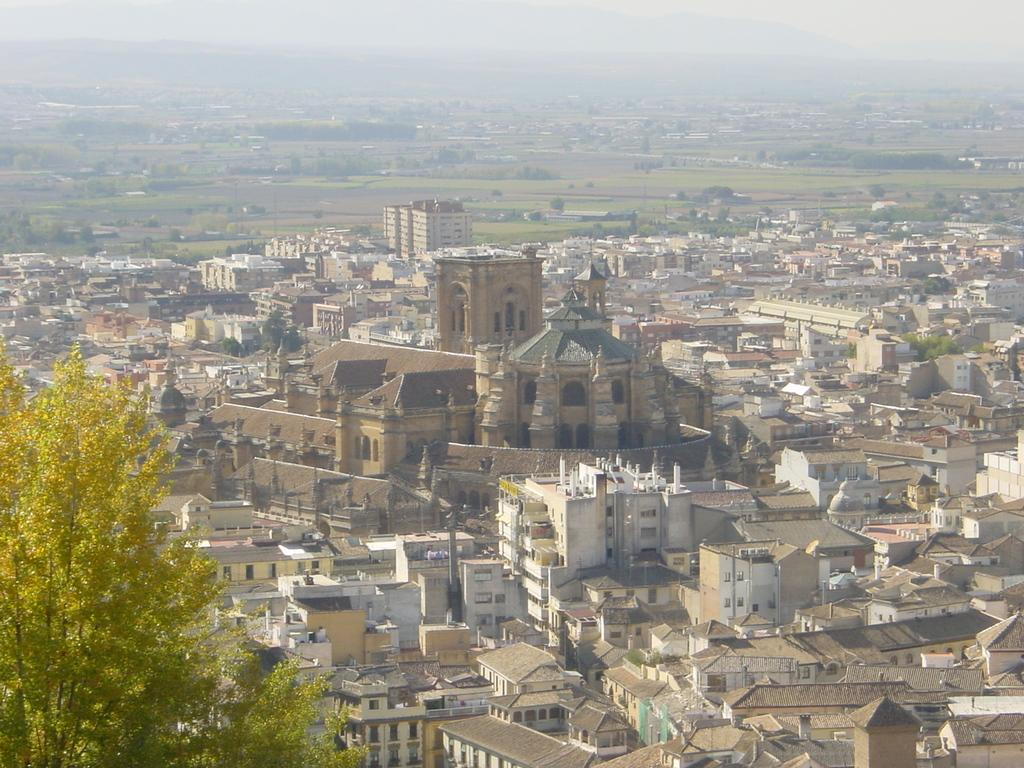What type of vegetation is present in the image? There are many trees and plants in the image. What type of structures can be seen in the image? There are houses and buildings in the image. What part of the natural environment is visible in the image? The sky is visible in the image. What type of terrain is present in the image? There is a grassy land in the image. What type of birthday celebration is taking place in the image? There is no indication of a birthday celebration in the image. Are there any servants visible in the image? There is no mention of servants in the image. 